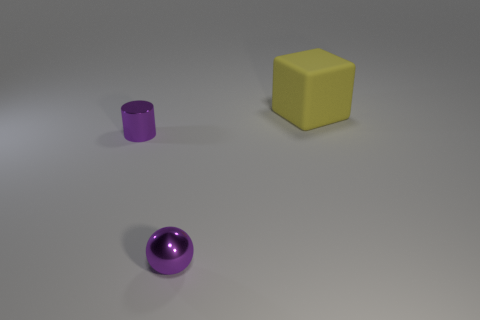Add 3 big yellow rubber blocks. How many objects exist? 6 Subtract all cubes. How many objects are left? 2 Subtract 0 brown balls. How many objects are left? 3 Subtract all small objects. Subtract all small purple matte cylinders. How many objects are left? 1 Add 1 purple balls. How many purple balls are left? 2 Add 2 tiny balls. How many tiny balls exist? 3 